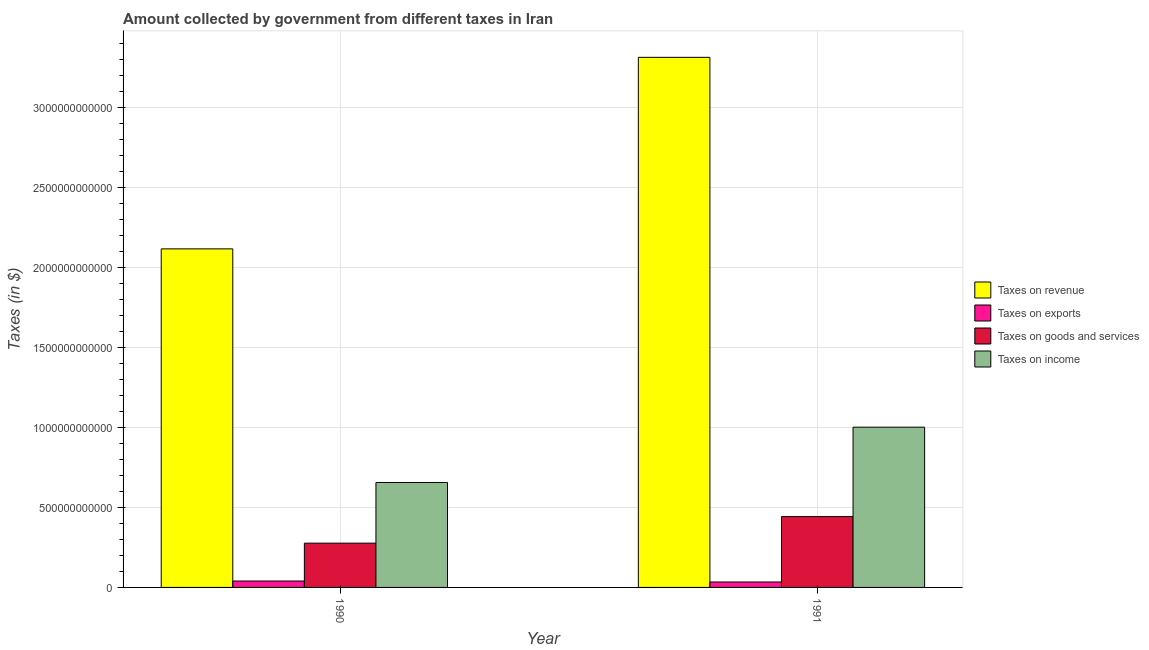How many different coloured bars are there?
Your answer should be compact. 4. How many groups of bars are there?
Your answer should be very brief. 2. Are the number of bars per tick equal to the number of legend labels?
Provide a succinct answer. Yes. How many bars are there on the 2nd tick from the left?
Your answer should be compact. 4. How many bars are there on the 2nd tick from the right?
Keep it short and to the point. 4. What is the label of the 1st group of bars from the left?
Your answer should be very brief. 1990. In how many cases, is the number of bars for a given year not equal to the number of legend labels?
Give a very brief answer. 0. What is the amount collected as tax on goods in 1991?
Your response must be concise. 4.43e+11. Across all years, what is the maximum amount collected as tax on income?
Your answer should be very brief. 1.00e+12. Across all years, what is the minimum amount collected as tax on goods?
Offer a very short reply. 2.77e+11. In which year was the amount collected as tax on income maximum?
Give a very brief answer. 1991. What is the total amount collected as tax on income in the graph?
Make the answer very short. 1.66e+12. What is the difference between the amount collected as tax on goods in 1990 and that in 1991?
Your answer should be very brief. -1.66e+11. What is the difference between the amount collected as tax on exports in 1991 and the amount collected as tax on goods in 1990?
Provide a succinct answer. -6.00e+09. What is the average amount collected as tax on income per year?
Give a very brief answer. 8.29e+11. In the year 1991, what is the difference between the amount collected as tax on exports and amount collected as tax on revenue?
Your response must be concise. 0. What is the ratio of the amount collected as tax on income in 1990 to that in 1991?
Your response must be concise. 0.65. Is the amount collected as tax on goods in 1990 less than that in 1991?
Provide a short and direct response. Yes. In how many years, is the amount collected as tax on income greater than the average amount collected as tax on income taken over all years?
Keep it short and to the point. 1. Is it the case that in every year, the sum of the amount collected as tax on exports and amount collected as tax on revenue is greater than the sum of amount collected as tax on goods and amount collected as tax on income?
Make the answer very short. Yes. What does the 1st bar from the left in 1991 represents?
Provide a short and direct response. Taxes on revenue. What does the 4th bar from the right in 1991 represents?
Your answer should be very brief. Taxes on revenue. Is it the case that in every year, the sum of the amount collected as tax on revenue and amount collected as tax on exports is greater than the amount collected as tax on goods?
Provide a short and direct response. Yes. Are all the bars in the graph horizontal?
Keep it short and to the point. No. What is the difference between two consecutive major ticks on the Y-axis?
Keep it short and to the point. 5.00e+11. Are the values on the major ticks of Y-axis written in scientific E-notation?
Your answer should be very brief. No. Does the graph contain any zero values?
Provide a short and direct response. No. How many legend labels are there?
Ensure brevity in your answer.  4. What is the title of the graph?
Make the answer very short. Amount collected by government from different taxes in Iran. Does "Burnt food" appear as one of the legend labels in the graph?
Your response must be concise. No. What is the label or title of the Y-axis?
Your answer should be very brief. Taxes (in $). What is the Taxes (in $) in Taxes on revenue in 1990?
Your answer should be very brief. 2.12e+12. What is the Taxes (in $) of Taxes on exports in 1990?
Your answer should be very brief. 4.00e+1. What is the Taxes (in $) in Taxes on goods and services in 1990?
Ensure brevity in your answer.  2.77e+11. What is the Taxes (in $) in Taxes on income in 1990?
Give a very brief answer. 6.56e+11. What is the Taxes (in $) of Taxes on revenue in 1991?
Offer a very short reply. 3.31e+12. What is the Taxes (in $) of Taxes on exports in 1991?
Give a very brief answer. 3.40e+1. What is the Taxes (in $) of Taxes on goods and services in 1991?
Your answer should be compact. 4.43e+11. What is the Taxes (in $) of Taxes on income in 1991?
Make the answer very short. 1.00e+12. Across all years, what is the maximum Taxes (in $) of Taxes on revenue?
Ensure brevity in your answer.  3.31e+12. Across all years, what is the maximum Taxes (in $) of Taxes on exports?
Offer a very short reply. 4.00e+1. Across all years, what is the maximum Taxes (in $) of Taxes on goods and services?
Ensure brevity in your answer.  4.43e+11. Across all years, what is the maximum Taxes (in $) of Taxes on income?
Your response must be concise. 1.00e+12. Across all years, what is the minimum Taxes (in $) of Taxes on revenue?
Make the answer very short. 2.12e+12. Across all years, what is the minimum Taxes (in $) of Taxes on exports?
Provide a short and direct response. 3.40e+1. Across all years, what is the minimum Taxes (in $) in Taxes on goods and services?
Your answer should be very brief. 2.77e+11. Across all years, what is the minimum Taxes (in $) of Taxes on income?
Keep it short and to the point. 6.56e+11. What is the total Taxes (in $) in Taxes on revenue in the graph?
Ensure brevity in your answer.  5.43e+12. What is the total Taxes (in $) in Taxes on exports in the graph?
Offer a terse response. 7.40e+1. What is the total Taxes (in $) in Taxes on goods and services in the graph?
Make the answer very short. 7.20e+11. What is the total Taxes (in $) of Taxes on income in the graph?
Ensure brevity in your answer.  1.66e+12. What is the difference between the Taxes (in $) of Taxes on revenue in 1990 and that in 1991?
Offer a terse response. -1.20e+12. What is the difference between the Taxes (in $) in Taxes on exports in 1990 and that in 1991?
Your response must be concise. 6.00e+09. What is the difference between the Taxes (in $) in Taxes on goods and services in 1990 and that in 1991?
Your answer should be very brief. -1.66e+11. What is the difference between the Taxes (in $) in Taxes on income in 1990 and that in 1991?
Provide a succinct answer. -3.46e+11. What is the difference between the Taxes (in $) in Taxes on revenue in 1990 and the Taxes (in $) in Taxes on exports in 1991?
Give a very brief answer. 2.08e+12. What is the difference between the Taxes (in $) in Taxes on revenue in 1990 and the Taxes (in $) in Taxes on goods and services in 1991?
Keep it short and to the point. 1.67e+12. What is the difference between the Taxes (in $) in Taxes on revenue in 1990 and the Taxes (in $) in Taxes on income in 1991?
Your answer should be compact. 1.11e+12. What is the difference between the Taxes (in $) in Taxes on exports in 1990 and the Taxes (in $) in Taxes on goods and services in 1991?
Keep it short and to the point. -4.03e+11. What is the difference between the Taxes (in $) of Taxes on exports in 1990 and the Taxes (in $) of Taxes on income in 1991?
Give a very brief answer. -9.62e+11. What is the difference between the Taxes (in $) of Taxes on goods and services in 1990 and the Taxes (in $) of Taxes on income in 1991?
Offer a terse response. -7.25e+11. What is the average Taxes (in $) in Taxes on revenue per year?
Give a very brief answer. 2.72e+12. What is the average Taxes (in $) in Taxes on exports per year?
Your answer should be very brief. 3.70e+1. What is the average Taxes (in $) in Taxes on goods and services per year?
Ensure brevity in your answer.  3.60e+11. What is the average Taxes (in $) in Taxes on income per year?
Your answer should be very brief. 8.29e+11. In the year 1990, what is the difference between the Taxes (in $) of Taxes on revenue and Taxes (in $) of Taxes on exports?
Offer a terse response. 2.08e+12. In the year 1990, what is the difference between the Taxes (in $) of Taxes on revenue and Taxes (in $) of Taxes on goods and services?
Offer a terse response. 1.84e+12. In the year 1990, what is the difference between the Taxes (in $) in Taxes on revenue and Taxes (in $) in Taxes on income?
Provide a short and direct response. 1.46e+12. In the year 1990, what is the difference between the Taxes (in $) in Taxes on exports and Taxes (in $) in Taxes on goods and services?
Make the answer very short. -2.37e+11. In the year 1990, what is the difference between the Taxes (in $) of Taxes on exports and Taxes (in $) of Taxes on income?
Your answer should be very brief. -6.16e+11. In the year 1990, what is the difference between the Taxes (in $) in Taxes on goods and services and Taxes (in $) in Taxes on income?
Provide a short and direct response. -3.79e+11. In the year 1991, what is the difference between the Taxes (in $) of Taxes on revenue and Taxes (in $) of Taxes on exports?
Your answer should be very brief. 3.28e+12. In the year 1991, what is the difference between the Taxes (in $) of Taxes on revenue and Taxes (in $) of Taxes on goods and services?
Ensure brevity in your answer.  2.87e+12. In the year 1991, what is the difference between the Taxes (in $) in Taxes on revenue and Taxes (in $) in Taxes on income?
Keep it short and to the point. 2.31e+12. In the year 1991, what is the difference between the Taxes (in $) in Taxes on exports and Taxes (in $) in Taxes on goods and services?
Ensure brevity in your answer.  -4.09e+11. In the year 1991, what is the difference between the Taxes (in $) of Taxes on exports and Taxes (in $) of Taxes on income?
Keep it short and to the point. -9.68e+11. In the year 1991, what is the difference between the Taxes (in $) of Taxes on goods and services and Taxes (in $) of Taxes on income?
Provide a short and direct response. -5.59e+11. What is the ratio of the Taxes (in $) of Taxes on revenue in 1990 to that in 1991?
Provide a succinct answer. 0.64. What is the ratio of the Taxes (in $) of Taxes on exports in 1990 to that in 1991?
Offer a very short reply. 1.18. What is the ratio of the Taxes (in $) in Taxes on goods and services in 1990 to that in 1991?
Your response must be concise. 0.62. What is the ratio of the Taxes (in $) in Taxes on income in 1990 to that in 1991?
Ensure brevity in your answer.  0.65. What is the difference between the highest and the second highest Taxes (in $) in Taxes on revenue?
Give a very brief answer. 1.20e+12. What is the difference between the highest and the second highest Taxes (in $) of Taxes on exports?
Provide a succinct answer. 6.00e+09. What is the difference between the highest and the second highest Taxes (in $) of Taxes on goods and services?
Your response must be concise. 1.66e+11. What is the difference between the highest and the second highest Taxes (in $) in Taxes on income?
Ensure brevity in your answer.  3.46e+11. What is the difference between the highest and the lowest Taxes (in $) of Taxes on revenue?
Make the answer very short. 1.20e+12. What is the difference between the highest and the lowest Taxes (in $) of Taxes on exports?
Your answer should be compact. 6.00e+09. What is the difference between the highest and the lowest Taxes (in $) of Taxes on goods and services?
Offer a terse response. 1.66e+11. What is the difference between the highest and the lowest Taxes (in $) of Taxes on income?
Your answer should be very brief. 3.46e+11. 